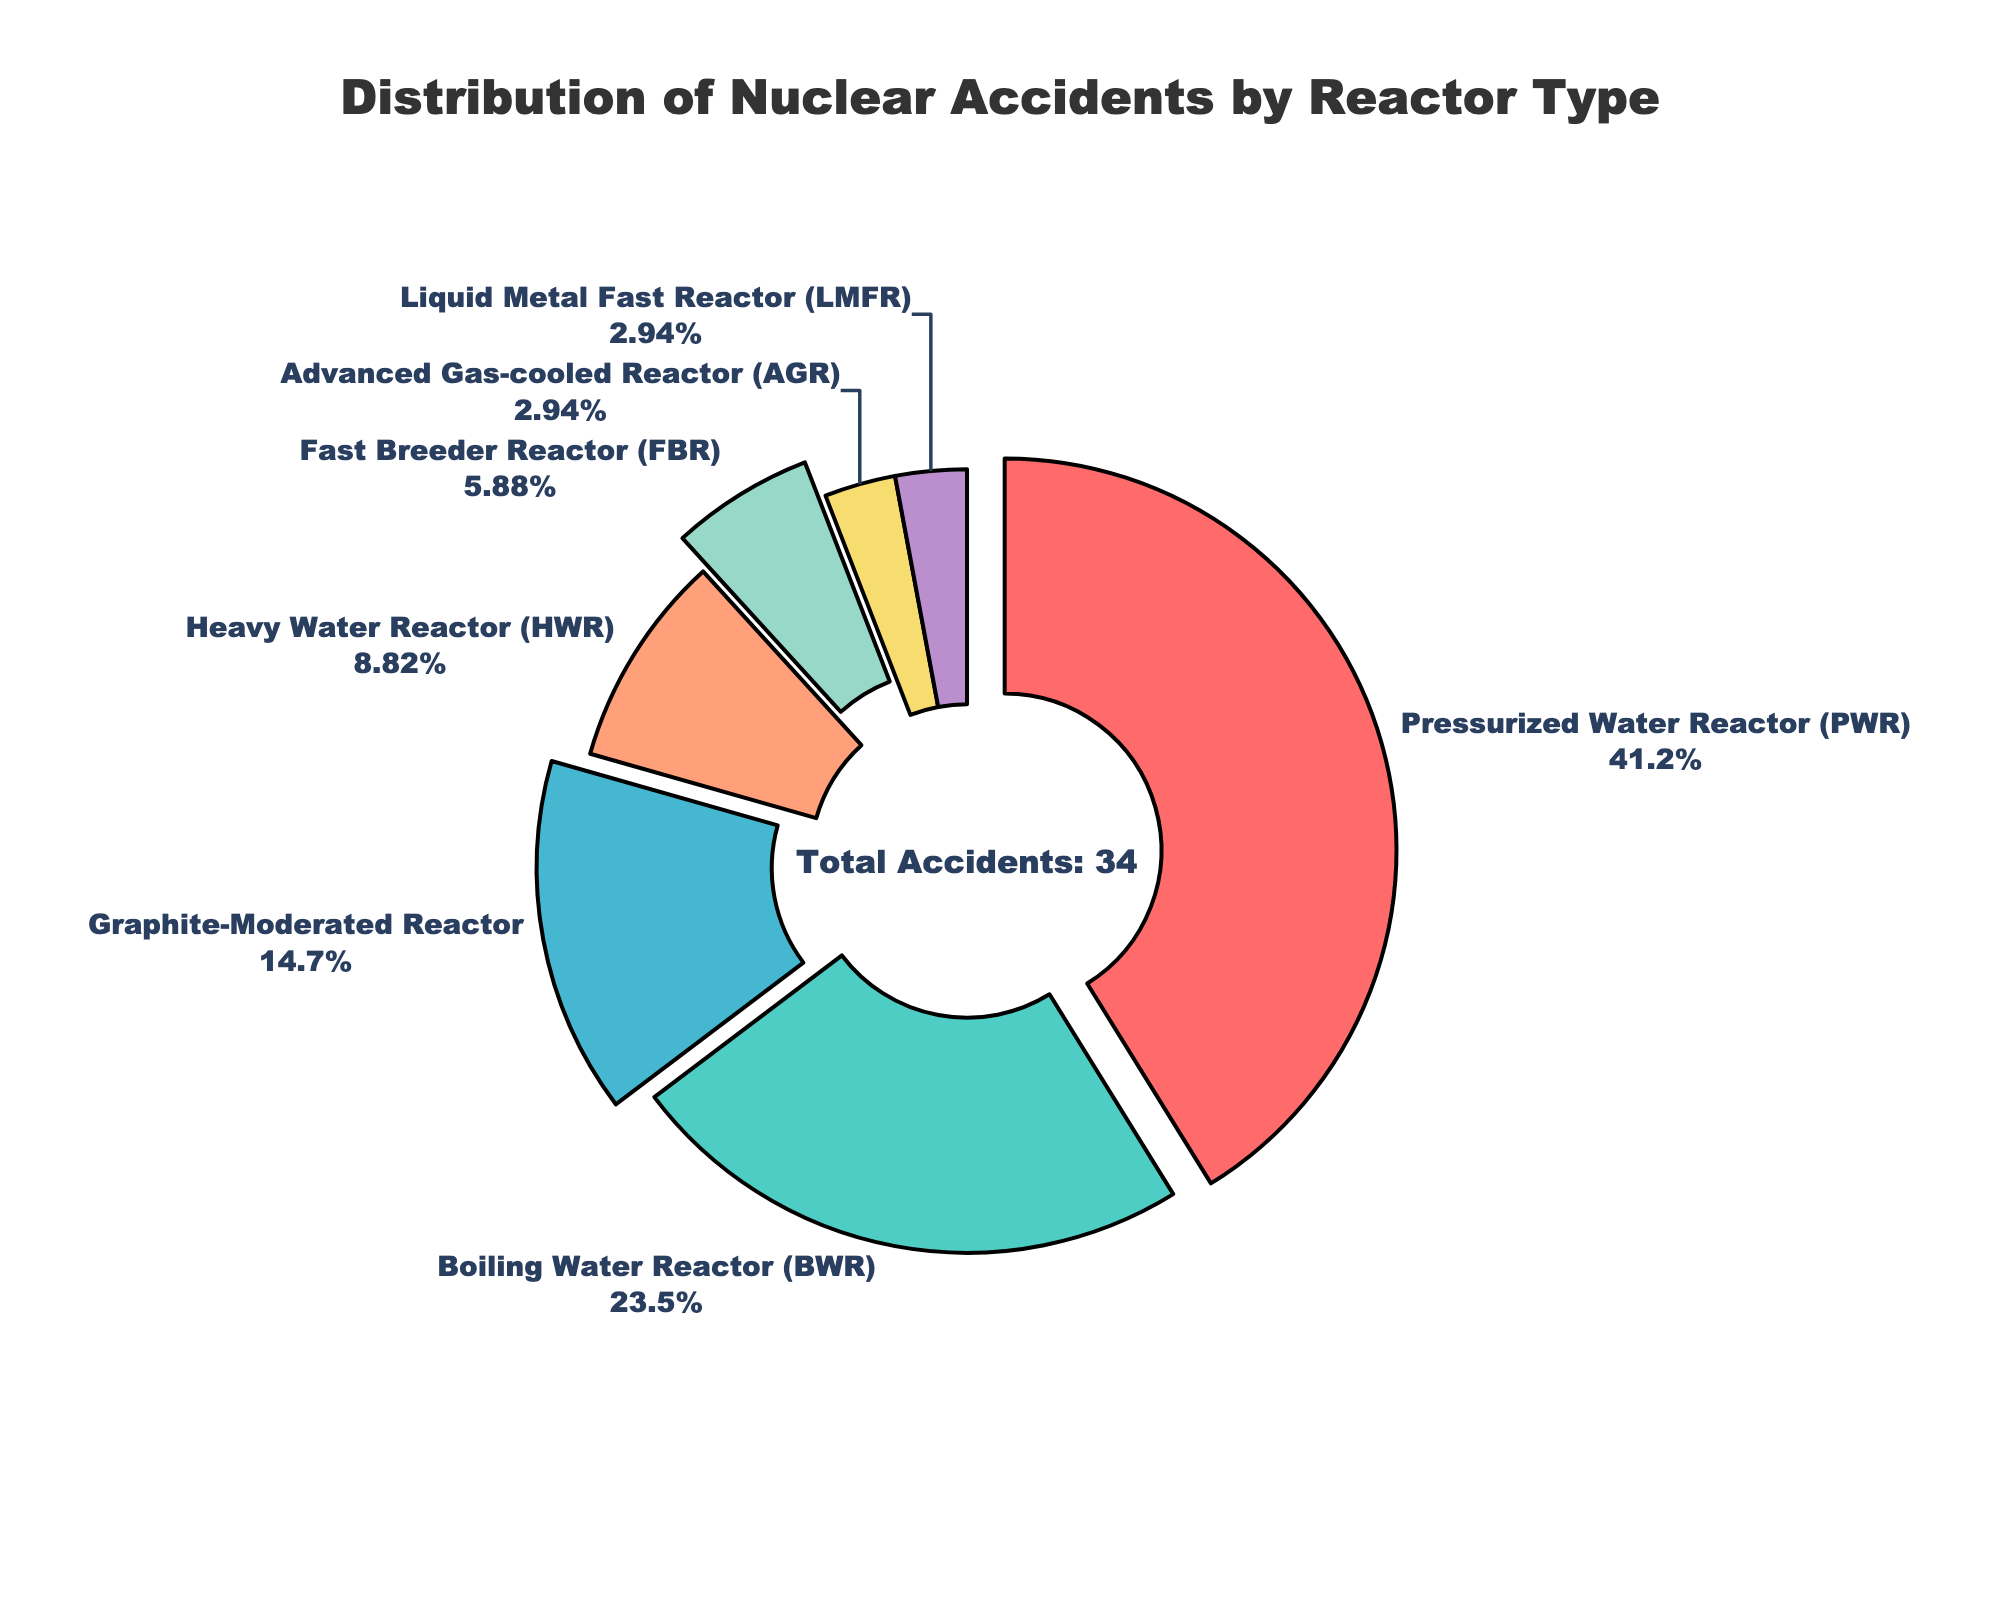Which reactor type has the highest number of accidents? The Pressurized Water Reactor (PWR) segment is the largest and shows the highest percentage.
Answer: Pressurized Water Reactor (PWR) What is the combined number of accidents for Boiling Water Reactor (BWR) and Heavy Water Reactor (HWR)? According to the figure, BWR has 8 accidents and HWR has 3 accidents; 8 + 3 = 11.
Answer: 11 Which two reactor types have the same number of accidents? Both the Advanced Gas-cooled Reactor (AGR) and Liquid Metal Fast Reactor (LMFR) segments are of equal size and represent 1 accident each.
Answer: Advanced Gas-cooled Reactor (AGR) and Liquid Metal Fast Reactor (LMFR) What is the percentage of accidents attributed to Graphite-Moderated Reactors? According to the figure, the Graphite-Moderated Reactor has a segment with the percentage label. It shows approximately 18%.
Answer: Approximately 18% Which reactor type has more accidents: Fast Breeder Reactor (FBR) or Heavy Water Reactor (HWR)? The Fast Breeder Reactor (FBR) has a smaller segment compared to Heavy Water Reactor (HWR). FBR has 2 accidents, and HWR has 3 accidents.
Answer: Heavy Water Reactor (HWR) How many more accidents does the Pressurized Water Reactor (PWR) have compared to the Boiling Water Reactor (BWR)? PWR has 14 accidents, and BWR has 8 accidents. The difference is 14 - 8 = 6.
Answer: 6 What is the color used for the segment with the fewest accidents? The segment with the fewest accidents belongs to the Advanced Gas-cooled Reactor (AGR) and Liquid Metal Fast Reactor (LMFR), which are yellow and purple respectively.
Answer: Yellow and purple Is the number of accidents for Graphite-Moderated Reactor greater than the sum of accidents for Fast Breeder Reactor (FBR) and Liquid Metal Fast Reactor (LMFR)? Graphite-Moderated Reactor has 5 accidents. Fast Breeder Reactor (FBR) and Liquid Metal Fast Reactor (LMFR) combined have 2 + 1 = 3 accidents. 5 > 3.
Answer: Yes What is the total number of accidents reported in the figure? The central annotation on the plot reads "Total Accidents: 34".
Answer: 34 